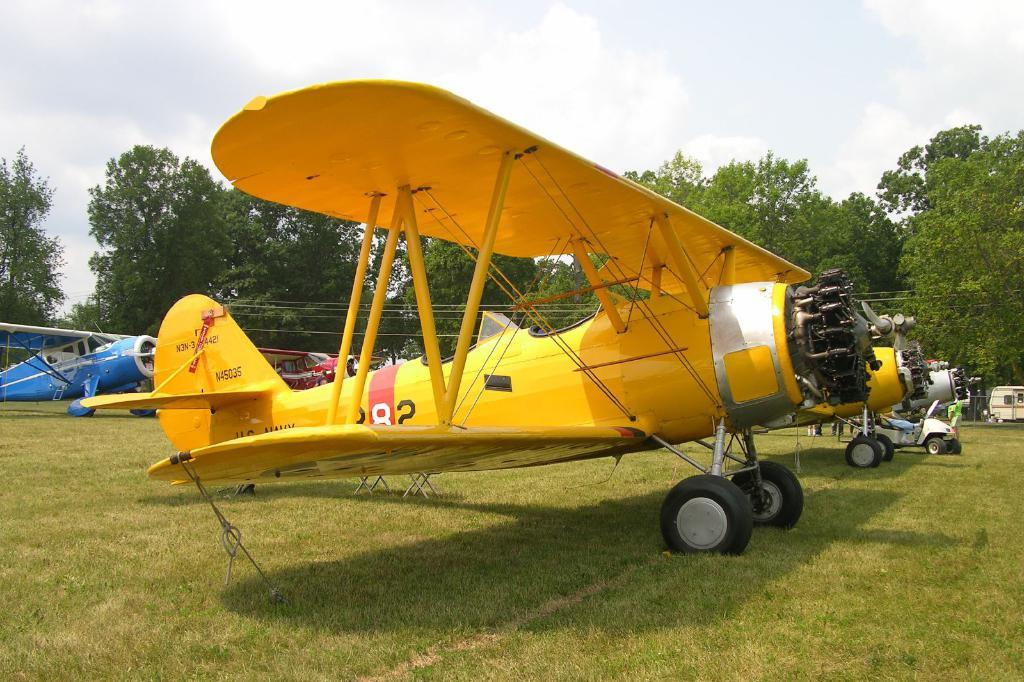<image>
Relay a brief, clear account of the picture shown. a yellow plane with N45035 written on the tail 